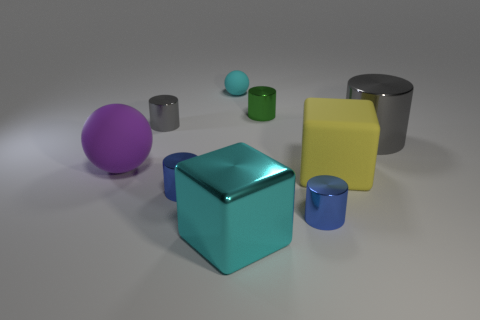Subtract all large gray shiny cylinders. How many cylinders are left? 4 Subtract all red balls. How many gray cylinders are left? 2 Subtract all blue cylinders. How many cylinders are left? 3 Subtract 3 cylinders. How many cylinders are left? 2 Add 9 cyan shiny objects. How many cyan shiny objects are left? 10 Add 2 tiny gray spheres. How many tiny gray spheres exist? 2 Subtract 1 green cylinders. How many objects are left? 8 Subtract all balls. How many objects are left? 7 Subtract all yellow cylinders. Subtract all green cubes. How many cylinders are left? 5 Subtract all tiny yellow cylinders. Subtract all large cyan things. How many objects are left? 8 